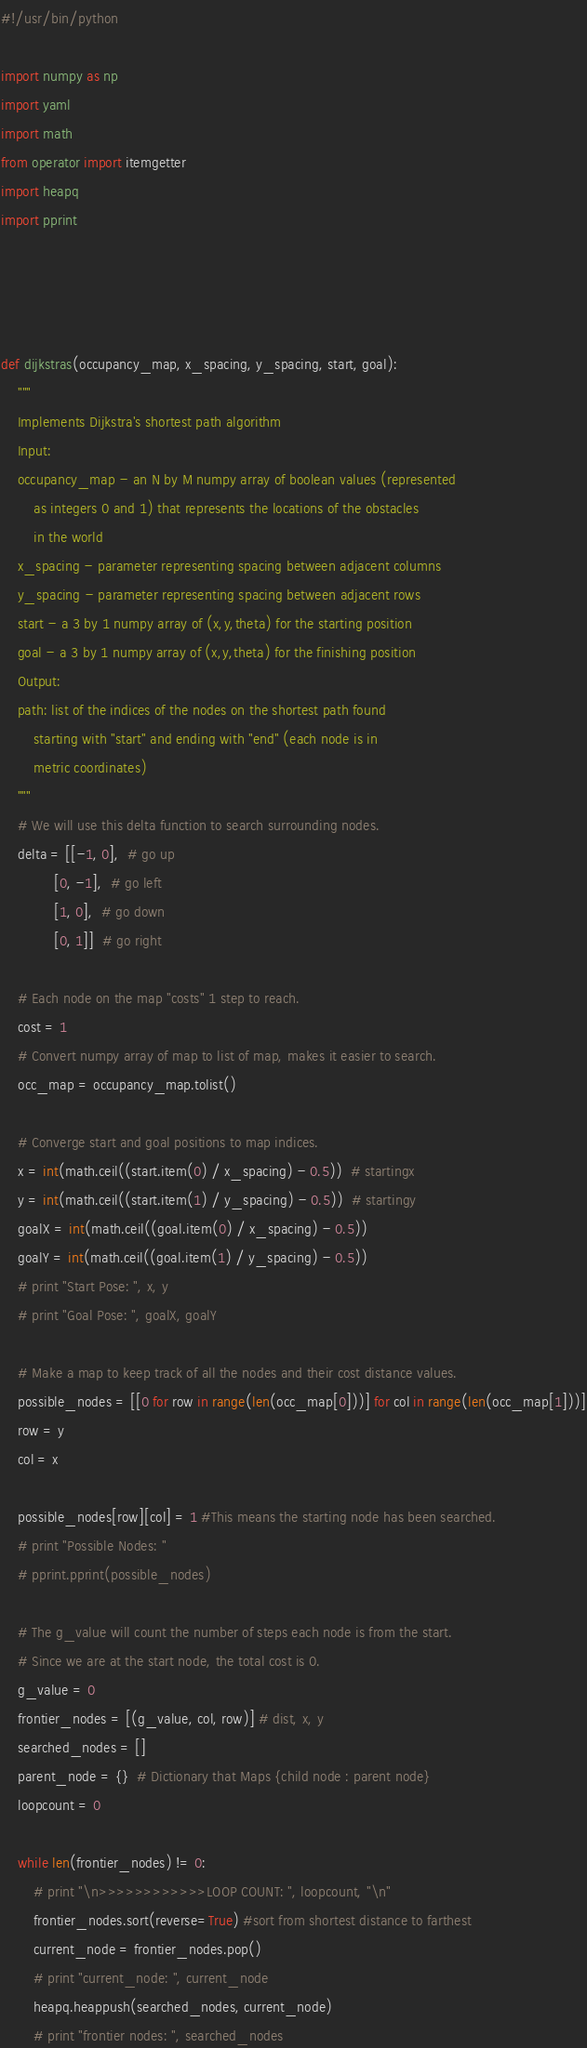Convert code to text. <code><loc_0><loc_0><loc_500><loc_500><_Python_>#!/usr/bin/python

import numpy as np
import yaml
import math
from operator import itemgetter
import heapq
import pprint




def dijkstras(occupancy_map, x_spacing, y_spacing, start, goal):
    """
    Implements Dijkstra's shortest path algorithm
    Input:
    occupancy_map - an N by M numpy array of boolean values (represented
        as integers 0 and 1) that represents the locations of the obstacles
        in the world
    x_spacing - parameter representing spacing between adjacent columns
    y_spacing - parameter representing spacing between adjacent rows
    start - a 3 by 1 numpy array of (x,y,theta) for the starting position 
    goal - a 3 by 1 numpy array of (x,y,theta) for the finishing position 
    Output: 
    path: list of the indices of the nodes on the shortest path found
        starting with "start" and ending with "end" (each node is in
        metric coordinates)
    """
    # We will use this delta function to search surrounding nodes.
    delta = [[-1, 0],  # go up
             [0, -1],  # go left
             [1, 0],  # go down
             [0, 1]]  # go right

    # Each node on the map "costs" 1 step to reach.
    cost = 1
    # Convert numpy array of map to list of map, makes it easier to search.
    occ_map = occupancy_map.tolist()

    # Converge start and goal positions to map indices.
    x = int(math.ceil((start.item(0) / x_spacing) - 0.5))  # startingx
    y = int(math.ceil((start.item(1) / y_spacing) - 0.5))  # startingy
    goalX = int(math.ceil((goal.item(0) / x_spacing) - 0.5))
    goalY = int(math.ceil((goal.item(1) / y_spacing) - 0.5))
    # print "Start Pose: ", x, y
    # print "Goal Pose: ", goalX, goalY

    # Make a map to keep track of all the nodes and their cost distance values.
    possible_nodes = [[0 for row in range(len(occ_map[0]))] for col in range(len(occ_map[1]))]
    row = y
    col = x

    possible_nodes[row][col] = 1 #This means the starting node has been searched.
    # print "Possible Nodes: "
    # pprint.pprint(possible_nodes)

    # The g_value will count the number of steps each node is from the start.
    # Since we are at the start node, the total cost is 0.
    g_value = 0
    frontier_nodes = [(g_value, col, row)] # dist, x, y
    searched_nodes = []
    parent_node = {}  # Dictionary that Maps {child node : parent node}
    loopcount = 0

    while len(frontier_nodes) != 0:
        # print "\n>>>>>>>>>>>>LOOP COUNT: ", loopcount, "\n"
        frontier_nodes.sort(reverse=True) #sort from shortest distance to farthest
        current_node = frontier_nodes.pop()
        # print "current_node: ", current_node
        heapq.heappush(searched_nodes, current_node)
        # print "frontier nodes: ", searched_nodes</code> 